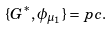Convert formula to latex. <formula><loc_0><loc_0><loc_500><loc_500>\{ G ^ { * } , \phi _ { \mu _ { 1 } } \} = p c .</formula> 